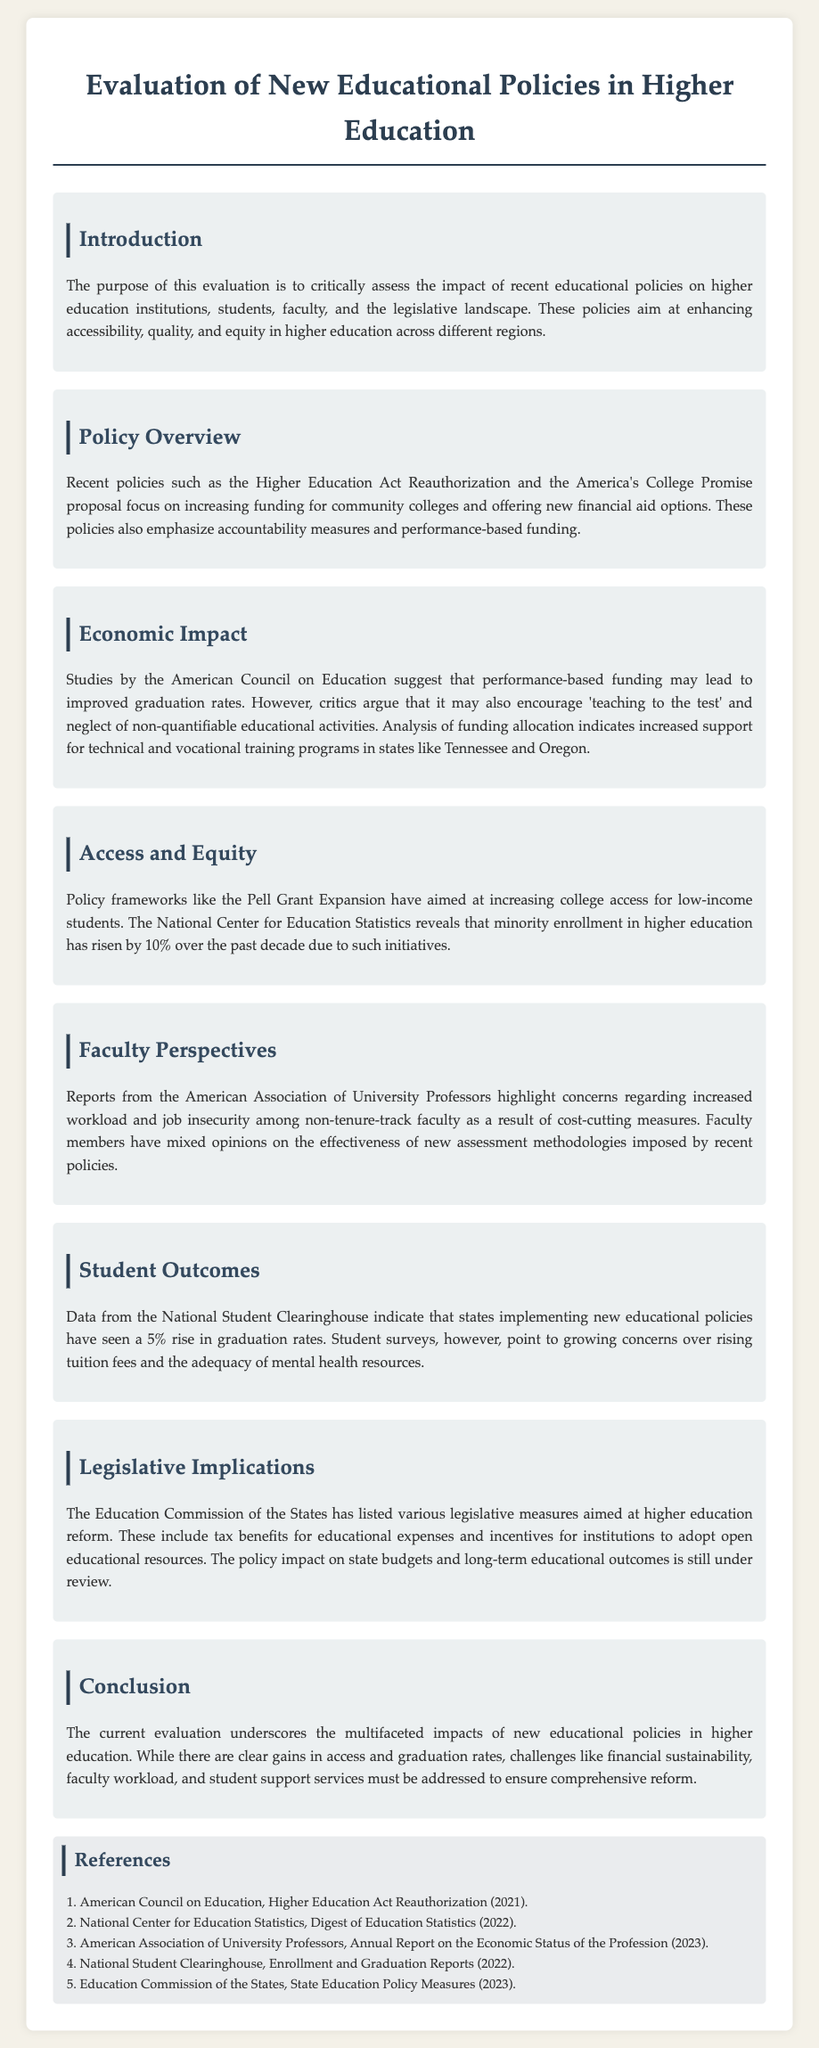what is the purpose of the evaluation? The purpose of this evaluation is to critically assess the impact of recent educational policies on higher education institutions, students, faculty, and the legislative landscape.
Answer: to critically assess the impact which act is mentioned in the policy overview? The policy overview discusses the Higher Education Act Reauthorization among other policies.
Answer: Higher Education Act Reauthorization what percentage increase in minority enrollment is reported? The document states that minority enrollment in higher education has risen by 10% over the past decade.
Answer: 10% what is the reported rise in graduation rates from states implementing new policies? Data indicates that states implementing new educational policies have seen a 5% rise in graduation rates.
Answer: 5% which group raised concerns about non-tenure-track faculty? Reports from the American Association of University Professors highlight concerns regarding this group.
Answer: American Association of University Professors what are the two highlighted challenges mentioned in the conclusion? The conclusion notes challenges such as financial sustainability and faculty workload.
Answer: financial sustainability, faculty workload which organization tracks enrollment and graduation data? The National Student Clearinghouse is mentioned as tracking these metrics.
Answer: National Student Clearinghouse what types of benefits are discussed in legislative implications? The legislative implications discuss tax benefits for educational expenses.
Answer: tax benefits 